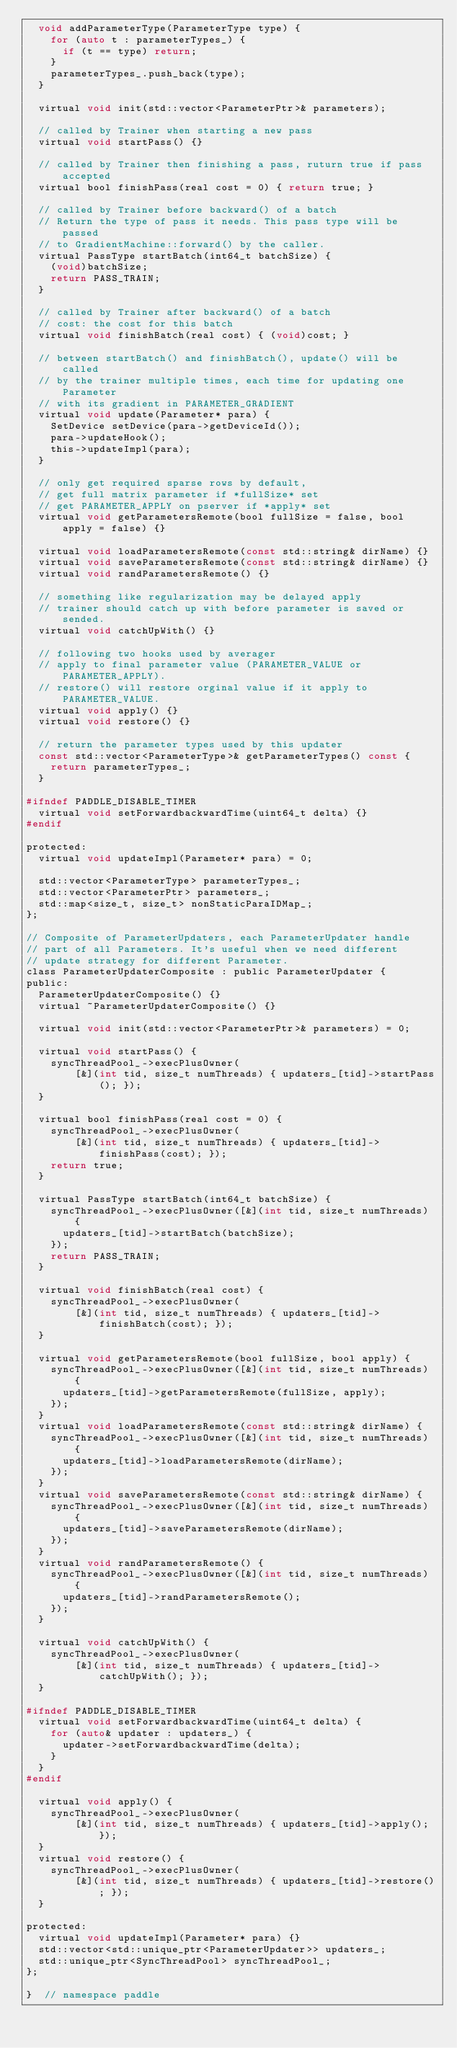<code> <loc_0><loc_0><loc_500><loc_500><_C_>  void addParameterType(ParameterType type) {
    for (auto t : parameterTypes_) {
      if (t == type) return;
    }
    parameterTypes_.push_back(type);
  }

  virtual void init(std::vector<ParameterPtr>& parameters);

  // called by Trainer when starting a new pass
  virtual void startPass() {}

  // called by Trainer then finishing a pass, ruturn true if pass accepted
  virtual bool finishPass(real cost = 0) { return true; }

  // called by Trainer before backward() of a batch
  // Return the type of pass it needs. This pass type will be passed
  // to GradientMachine::forward() by the caller.
  virtual PassType startBatch(int64_t batchSize) {
    (void)batchSize;
    return PASS_TRAIN;
  }

  // called by Trainer after backward() of a batch
  // cost: the cost for this batch
  virtual void finishBatch(real cost) { (void)cost; }

  // between startBatch() and finishBatch(), update() will be called
  // by the trainer multiple times, each time for updating one Parameter
  // with its gradient in PARAMETER_GRADIENT
  virtual void update(Parameter* para) {
    SetDevice setDevice(para->getDeviceId());
    para->updateHook();
    this->updateImpl(para);
  }

  // only get required sparse rows by default,
  // get full matrix parameter if *fullSize* set
  // get PARAMETER_APPLY on pserver if *apply* set
  virtual void getParametersRemote(bool fullSize = false, bool apply = false) {}

  virtual void loadParametersRemote(const std::string& dirName) {}
  virtual void saveParametersRemote(const std::string& dirName) {}
  virtual void randParametersRemote() {}

  // something like regularization may be delayed apply
  // trainer should catch up with before parameter is saved or sended.
  virtual void catchUpWith() {}

  // following two hooks used by averager
  // apply to final parameter value (PARAMETER_VALUE or PARAMETER_APPLY).
  // restore() will restore orginal value if it apply to PARAMETER_VALUE.
  virtual void apply() {}
  virtual void restore() {}

  // return the parameter types used by this updater
  const std::vector<ParameterType>& getParameterTypes() const {
    return parameterTypes_;
  }

#ifndef PADDLE_DISABLE_TIMER
  virtual void setForwardbackwardTime(uint64_t delta) {}
#endif

protected:
  virtual void updateImpl(Parameter* para) = 0;

  std::vector<ParameterType> parameterTypes_;
  std::vector<ParameterPtr> parameters_;
  std::map<size_t, size_t> nonStaticParaIDMap_;
};

// Composite of ParameterUpdaters, each ParameterUpdater handle
// part of all Parameters. It's useful when we need different
// update strategy for different Parameter.
class ParameterUpdaterComposite : public ParameterUpdater {
public:
  ParameterUpdaterComposite() {}
  virtual ~ParameterUpdaterComposite() {}

  virtual void init(std::vector<ParameterPtr>& parameters) = 0;

  virtual void startPass() {
    syncThreadPool_->execPlusOwner(
        [&](int tid, size_t numThreads) { updaters_[tid]->startPass(); });
  }

  virtual bool finishPass(real cost = 0) {
    syncThreadPool_->execPlusOwner(
        [&](int tid, size_t numThreads) { updaters_[tid]->finishPass(cost); });
    return true;
  }

  virtual PassType startBatch(int64_t batchSize) {
    syncThreadPool_->execPlusOwner([&](int tid, size_t numThreads) {
      updaters_[tid]->startBatch(batchSize);
    });
    return PASS_TRAIN;
  }

  virtual void finishBatch(real cost) {
    syncThreadPool_->execPlusOwner(
        [&](int tid, size_t numThreads) { updaters_[tid]->finishBatch(cost); });
  }

  virtual void getParametersRemote(bool fullSize, bool apply) {
    syncThreadPool_->execPlusOwner([&](int tid, size_t numThreads) {
      updaters_[tid]->getParametersRemote(fullSize, apply);
    });
  }
  virtual void loadParametersRemote(const std::string& dirName) {
    syncThreadPool_->execPlusOwner([&](int tid, size_t numThreads) {
      updaters_[tid]->loadParametersRemote(dirName);
    });
  }
  virtual void saveParametersRemote(const std::string& dirName) {
    syncThreadPool_->execPlusOwner([&](int tid, size_t numThreads) {
      updaters_[tid]->saveParametersRemote(dirName);
    });
  }
  virtual void randParametersRemote() {
    syncThreadPool_->execPlusOwner([&](int tid, size_t numThreads) {
      updaters_[tid]->randParametersRemote();
    });
  }

  virtual void catchUpWith() {
    syncThreadPool_->execPlusOwner(
        [&](int tid, size_t numThreads) { updaters_[tid]->catchUpWith(); });
  }

#ifndef PADDLE_DISABLE_TIMER
  virtual void setForwardbackwardTime(uint64_t delta) {
    for (auto& updater : updaters_) {
      updater->setForwardbackwardTime(delta);
    }
  }
#endif

  virtual void apply() {
    syncThreadPool_->execPlusOwner(
        [&](int tid, size_t numThreads) { updaters_[tid]->apply(); });
  }
  virtual void restore() {
    syncThreadPool_->execPlusOwner(
        [&](int tid, size_t numThreads) { updaters_[tid]->restore(); });
  }

protected:
  virtual void updateImpl(Parameter* para) {}
  std::vector<std::unique_ptr<ParameterUpdater>> updaters_;
  std::unique_ptr<SyncThreadPool> syncThreadPool_;
};

}  // namespace paddle
</code> 